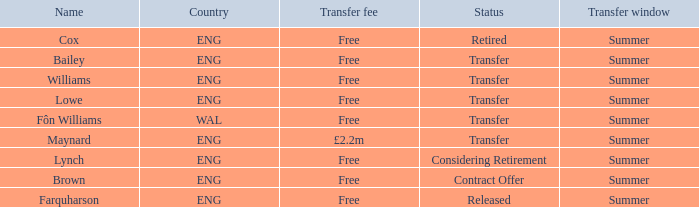What is the name of the free transfer fee with a transfer status and an ENG country? Bailey, Williams, Lowe. 